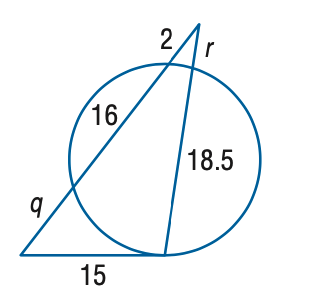Question: Find the variable of r to the nearest tenth. Assume that segments that appear to be tangent are tangent.
Choices:
A. 0.8
B. 1.8
C. 2.8
D. 3.8
Answer with the letter. Answer: B Question: Find the variable of q to the nearest tenth. Assume that segments that appear to be tangent are tangent.
Choices:
A. 6.0
B. 7.0
C. 8.0
D. 9.0
Answer with the letter. Answer: D 